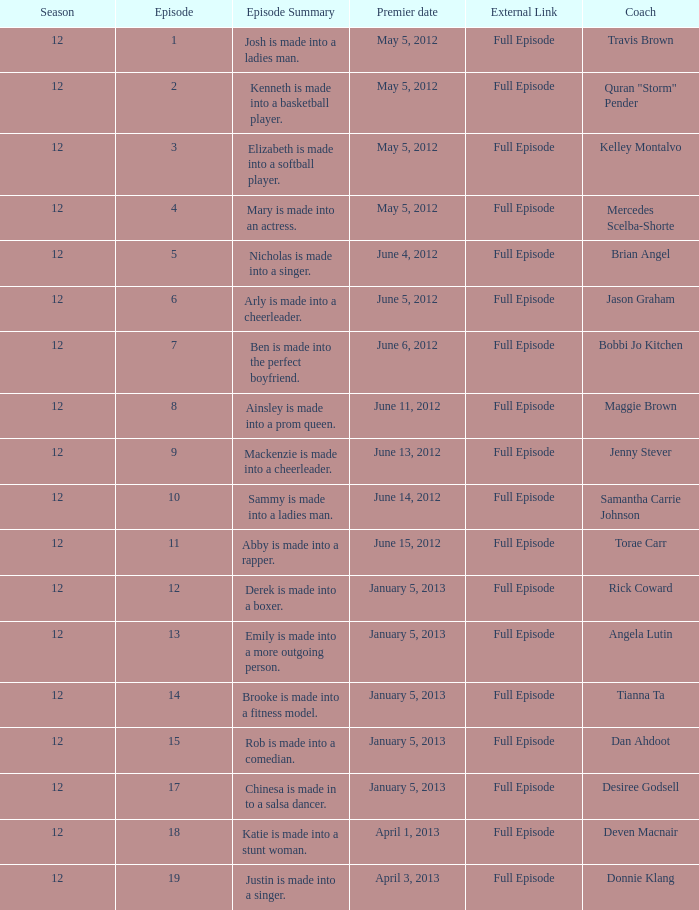Write the full table. {'header': ['Season', 'Episode', 'Episode Summary', 'Premier date', 'External Link', 'Coach'], 'rows': [['12', '1', 'Josh is made into a ladies man.', 'May 5, 2012', 'Full Episode', 'Travis Brown'], ['12', '2', 'Kenneth is made into a basketball player.', 'May 5, 2012', 'Full Episode', 'Quran "Storm" Pender'], ['12', '3', 'Elizabeth is made into a softball player.', 'May 5, 2012', 'Full Episode', 'Kelley Montalvo'], ['12', '4', 'Mary is made into an actress.', 'May 5, 2012', 'Full Episode', 'Mercedes Scelba-Shorte'], ['12', '5', 'Nicholas is made into a singer.', 'June 4, 2012', 'Full Episode', 'Brian Angel'], ['12', '6', 'Arly is made into a cheerleader.', 'June 5, 2012', 'Full Episode', 'Jason Graham'], ['12', '7', 'Ben is made into the perfect boyfriend.', 'June 6, 2012', 'Full Episode', 'Bobbi Jo Kitchen'], ['12', '8', 'Ainsley is made into a prom queen.', 'June 11, 2012', 'Full Episode', 'Maggie Brown'], ['12', '9', 'Mackenzie is made into a cheerleader.', 'June 13, 2012', 'Full Episode', 'Jenny Stever'], ['12', '10', 'Sammy is made into a ladies man.', 'June 14, 2012', 'Full Episode', 'Samantha Carrie Johnson'], ['12', '11', 'Abby is made into a rapper.', 'June 15, 2012', 'Full Episode', 'Torae Carr'], ['12', '12', 'Derek is made into a boxer.', 'January 5, 2013', 'Full Episode', 'Rick Coward'], ['12', '13', 'Emily is made into a more outgoing person.', 'January 5, 2013', 'Full Episode', 'Angela Lutin'], ['12', '14', 'Brooke is made into a fitness model.', 'January 5, 2013', 'Full Episode', 'Tianna Ta'], ['12', '15', 'Rob is made into a comedian.', 'January 5, 2013', 'Full Episode', 'Dan Ahdoot'], ['12', '17', 'Chinesa is made in to a salsa dancer.', 'January 5, 2013', 'Full Episode', 'Desiree Godsell'], ['12', '18', 'Katie is made into a stunt woman.', 'April 1, 2013', 'Full Episode', 'Deven Macnair'], ['12', '19', 'Justin is made into a singer.', 'April 3, 2013', 'Full Episode', 'Donnie Klang']]} Provide the episode outline for torae carr. Abby is made into a rapper. 